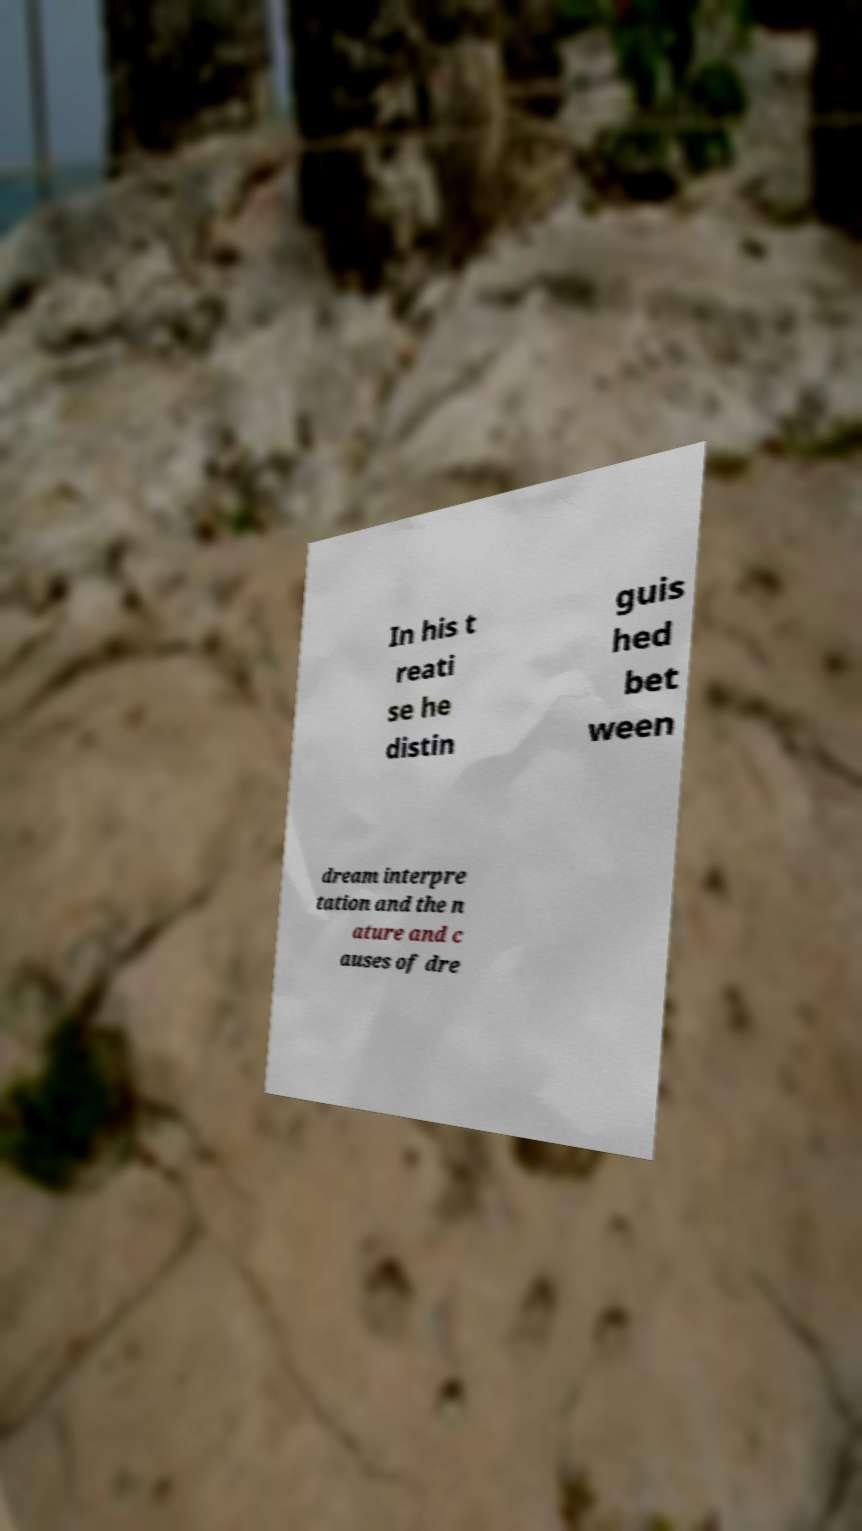For documentation purposes, I need the text within this image transcribed. Could you provide that? In his t reati se he distin guis hed bet ween dream interpre tation and the n ature and c auses of dre 